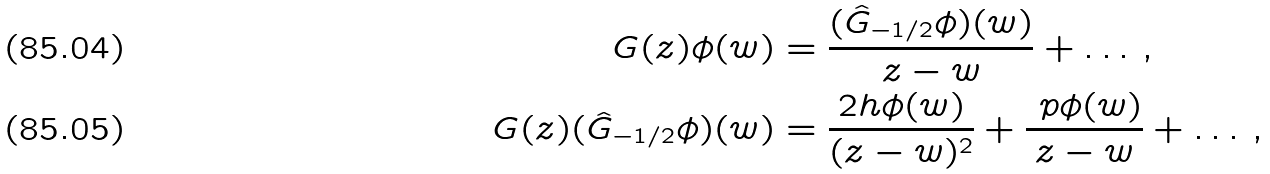Convert formula to latex. <formula><loc_0><loc_0><loc_500><loc_500>G ( z ) \phi ( w ) & = \frac { ( \hat { G } _ { - 1 / 2 } \phi ) ( w ) } { z - w } + \dots \, , \\ G ( z ) ( \hat { G } _ { - 1 / 2 } \phi ) ( w ) & = \frac { 2 h \phi ( w ) } { ( z - w ) ^ { 2 } } + \frac { \ p \phi ( w ) } { z - w } + \dots \, ,</formula> 